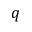<formula> <loc_0><loc_0><loc_500><loc_500>q</formula> 